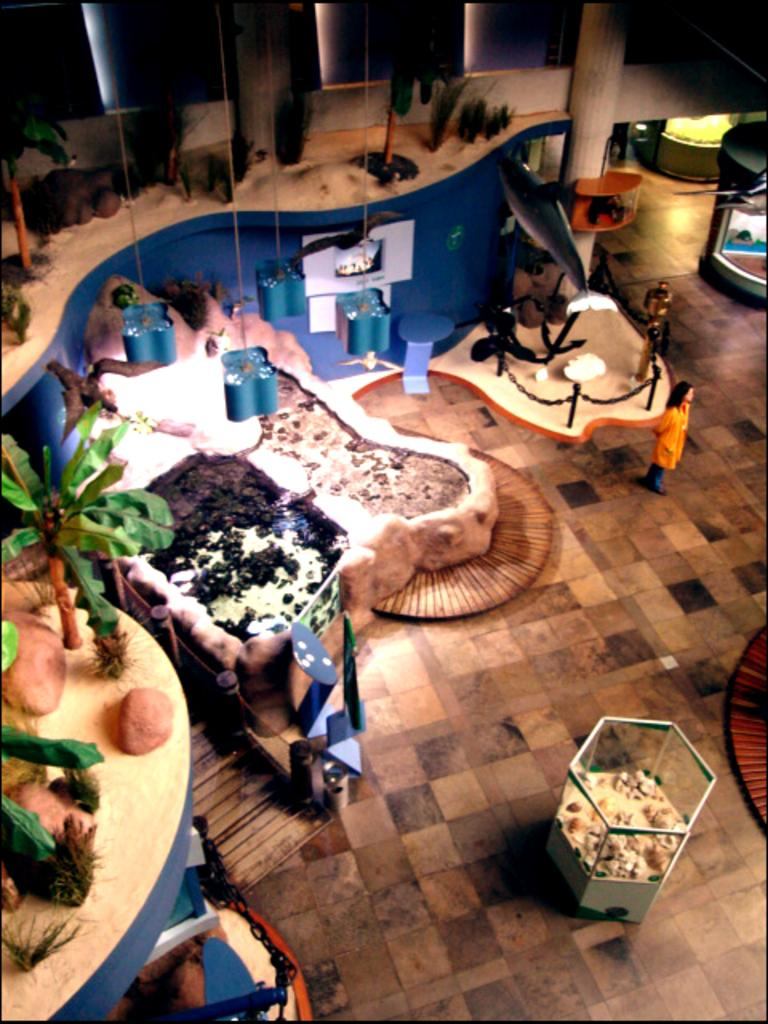What is the main object in the image? There is a box in the image. What can be seen in the image besides the box? There are lights, plants, stones, and other objects on the table in the image. Can you describe the table setting in the image? The table has plants, stones, and other objects on it. What is located at the top of the image? There is a small fridge on the top of the image. What type of rhythm can be heard coming from the plants in the image? There is no rhythm coming from the plants in the image, as plants do not produce sound. 